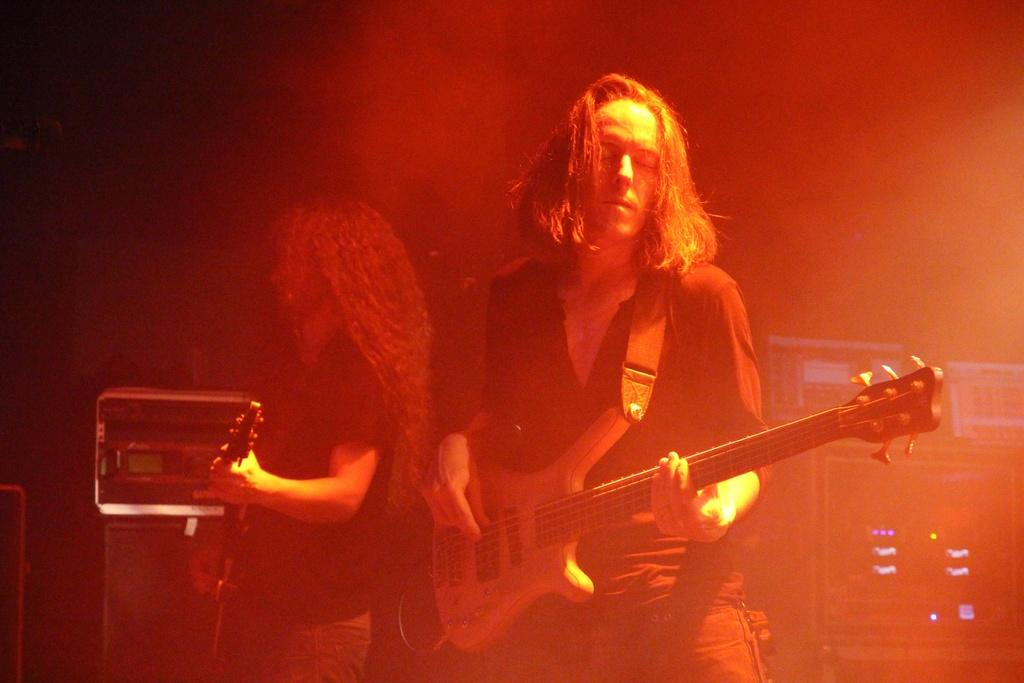How many persons are in the foreground of the image? There are two persons in the foreground of the image. What are the persons in the image doing? The persons are holding musical instruments. What can be seen in the background of the image? There are music systems, lights, and some objects in the background of the image. What type of bone can be seen in the image? There is no bone present in the image. Is there a cemetery visible in the image? No, there is no cemetery visible in the image. 